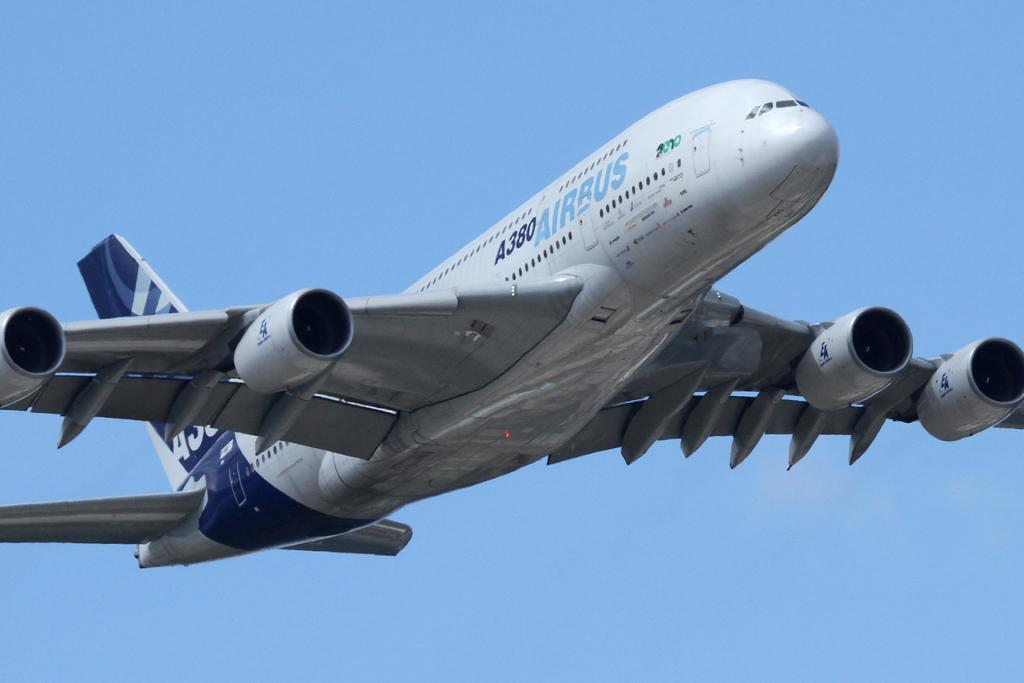<image>
Relay a brief, clear account of the picture shown. a blue and silver airplane mid flight with the logo for air rus on its side. 